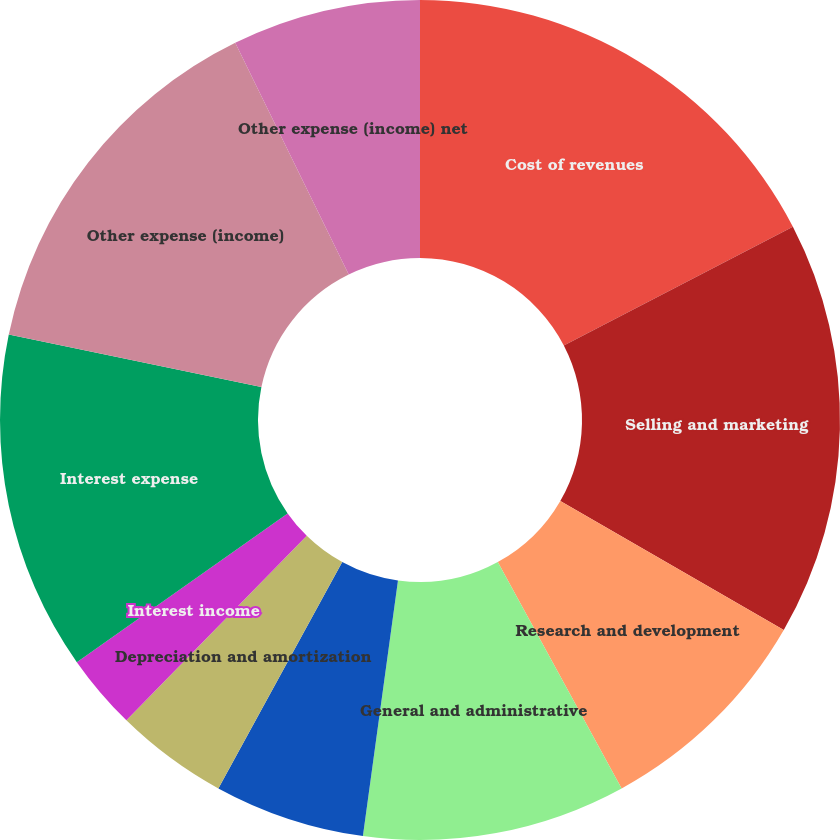Convert chart to OTSL. <chart><loc_0><loc_0><loc_500><loc_500><pie_chart><fcel>Cost of revenues<fcel>Selling and marketing<fcel>Research and development<fcel>General and administrative<fcel>Amortization of intangible<fcel>Depreciation and amortization<fcel>Interest income<fcel>Interest expense<fcel>Other expense (income)<fcel>Other expense (income) net<nl><fcel>17.39%<fcel>15.94%<fcel>8.7%<fcel>10.14%<fcel>5.8%<fcel>4.35%<fcel>2.9%<fcel>13.04%<fcel>14.49%<fcel>7.25%<nl></chart> 